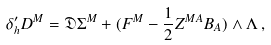Convert formula to latex. <formula><loc_0><loc_0><loc_500><loc_500>\delta ^ { \prime } _ { h } D ^ { M } = \mathfrak { D } \Sigma ^ { M } + ( F ^ { M } - { \frac { 1 } { 2 } Z ^ { M A } B _ { A } } ) \wedge \Lambda \, ,</formula> 